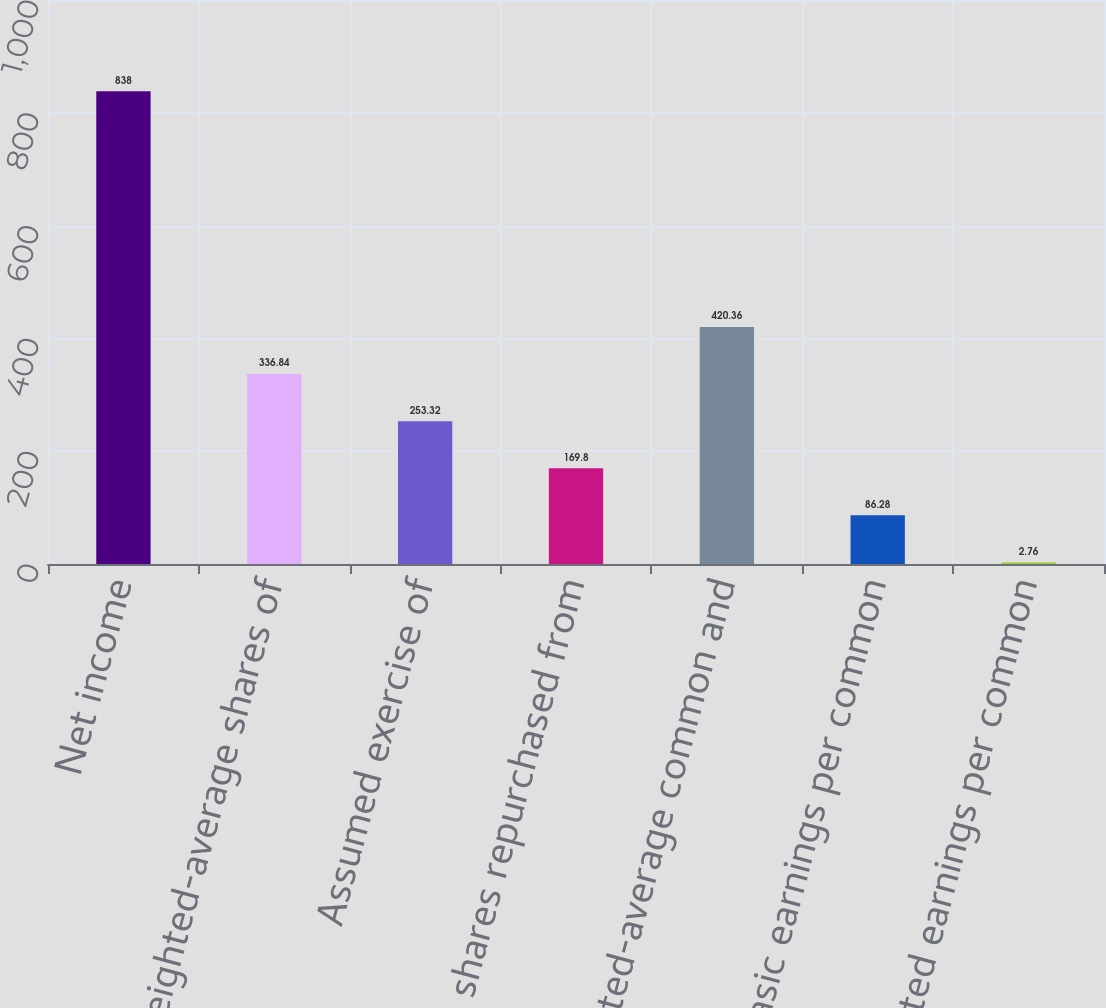Convert chart. <chart><loc_0><loc_0><loc_500><loc_500><bar_chart><fcel>Net income<fcel>Weighted-average shares of<fcel>Assumed exercise of<fcel>Less shares repurchased from<fcel>Weighted-average common and<fcel>Basic earnings per common<fcel>Diluted earnings per common<nl><fcel>838<fcel>336.84<fcel>253.32<fcel>169.8<fcel>420.36<fcel>86.28<fcel>2.76<nl></chart> 